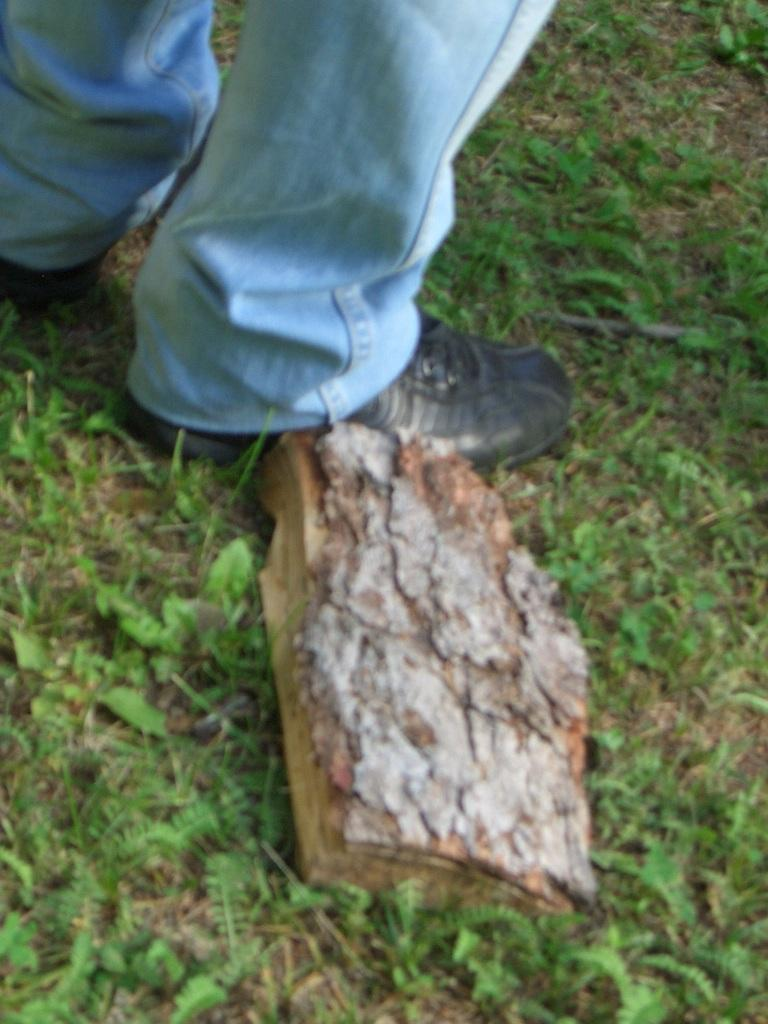What is located on the grassland in the image? There is a wooden piece on the grassland in the image. Where is the wooden piece situated in relation to the image? The wooden piece is in the foreground area of the image. Can you describe any other elements visible in the image? Yes, there are legs of a person visible at the top side of the image. What type of smell can be detected from the wooden piece in the image? There is no information about the smell of the wooden piece in the image, so it cannot be determined. 